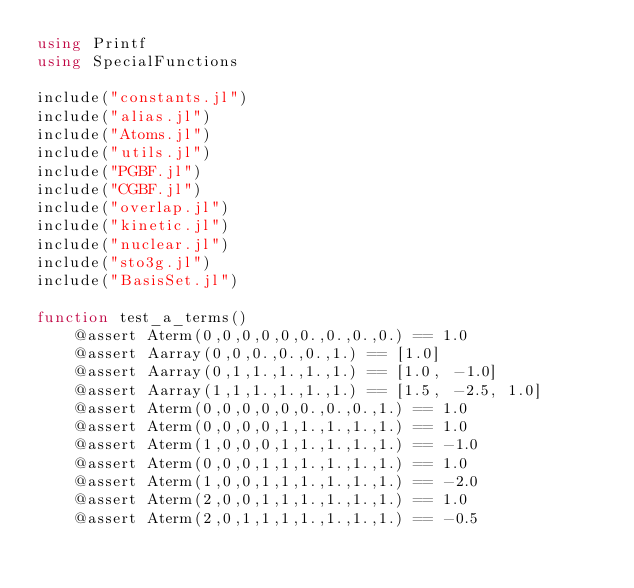<code> <loc_0><loc_0><loc_500><loc_500><_Julia_>using Printf
using SpecialFunctions

include("constants.jl")
include("alias.jl")
include("Atoms.jl")
include("utils.jl")
include("PGBF.jl")
include("CGBF.jl")
include("overlap.jl")
include("kinetic.jl")
include("nuclear.jl")
include("sto3g.jl")
include("BasisSet.jl")

function test_a_terms()
    @assert Aterm(0,0,0,0,0,0.,0.,0.,0.) == 1.0
    @assert Aarray(0,0,0.,0.,0.,1.) == [1.0]
    @assert Aarray(0,1,1.,1.,1.,1.) == [1.0, -1.0]
    @assert Aarray(1,1,1.,1.,1.,1.) == [1.5, -2.5, 1.0]
    @assert Aterm(0,0,0,0,0,0.,0.,0.,1.) == 1.0
    @assert Aterm(0,0,0,0,1,1.,1.,1.,1.) == 1.0
    @assert Aterm(1,0,0,0,1,1.,1.,1.,1.) == -1.0
    @assert Aterm(0,0,0,1,1,1.,1.,1.,1.) == 1.0
    @assert Aterm(1,0,0,1,1,1.,1.,1.,1.) == -2.0
    @assert Aterm(2,0,0,1,1,1.,1.,1.,1.) == 1.0
    @assert Aterm(2,0,1,1,1,1.,1.,1.,1.) == -0.5</code> 